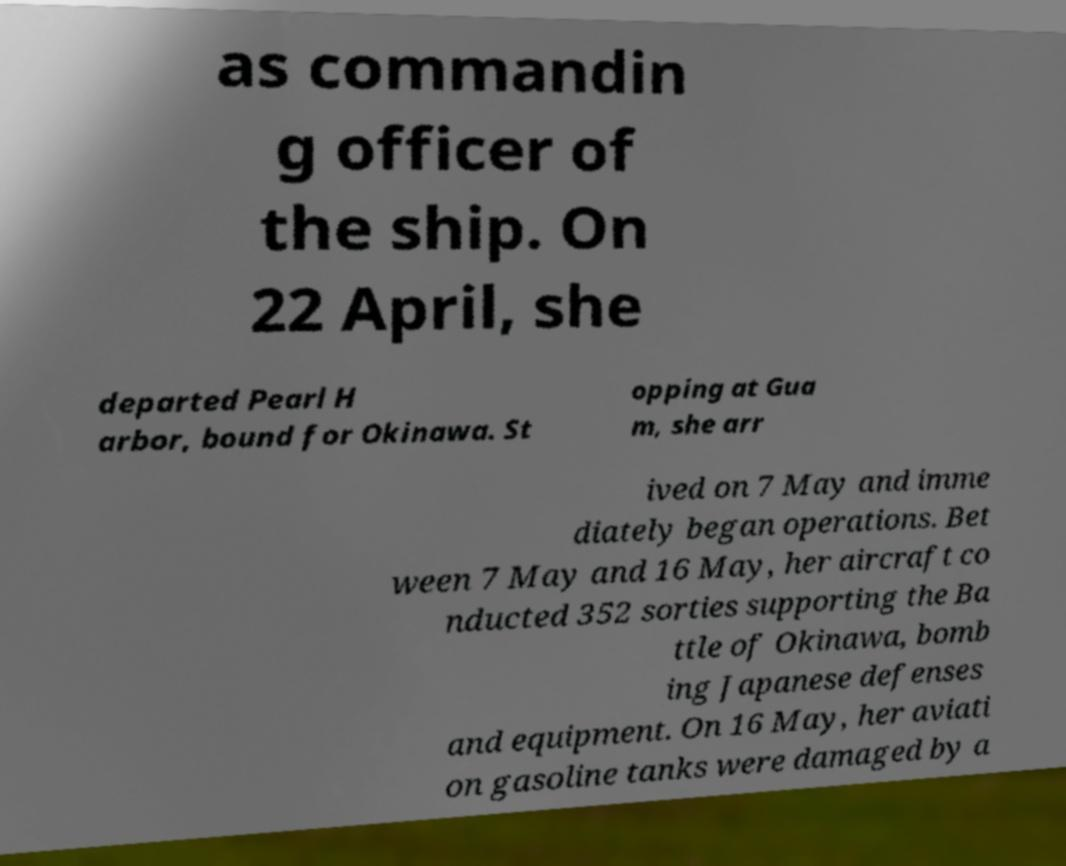Please identify and transcribe the text found in this image. as commandin g officer of the ship. On 22 April, she departed Pearl H arbor, bound for Okinawa. St opping at Gua m, she arr ived on 7 May and imme diately began operations. Bet ween 7 May and 16 May, her aircraft co nducted 352 sorties supporting the Ba ttle of Okinawa, bomb ing Japanese defenses and equipment. On 16 May, her aviati on gasoline tanks were damaged by a 